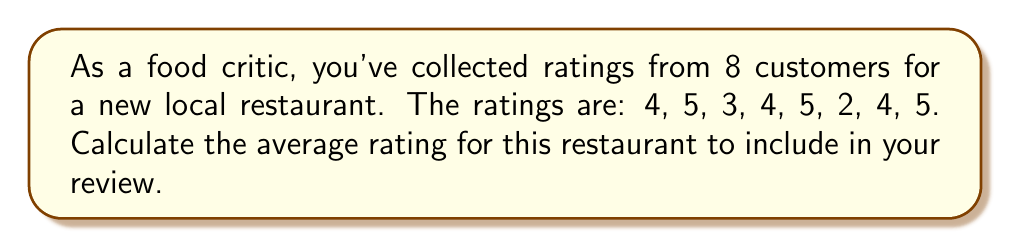Can you answer this question? To calculate the average rating, we need to follow these steps:

1. Sum up all the ratings:
   $4 + 5 + 3 + 4 + 5 + 2 + 4 + 5 = 32$

2. Count the total number of ratings:
   There are 8 ratings in total.

3. Divide the sum by the total number of ratings:
   $$\text{Average} = \frac{\text{Sum of ratings}}{\text{Number of ratings}} = \frac{32}{8} = 4$$

Therefore, the average rating for the restaurant is 4 out of 5.
Answer: 4 